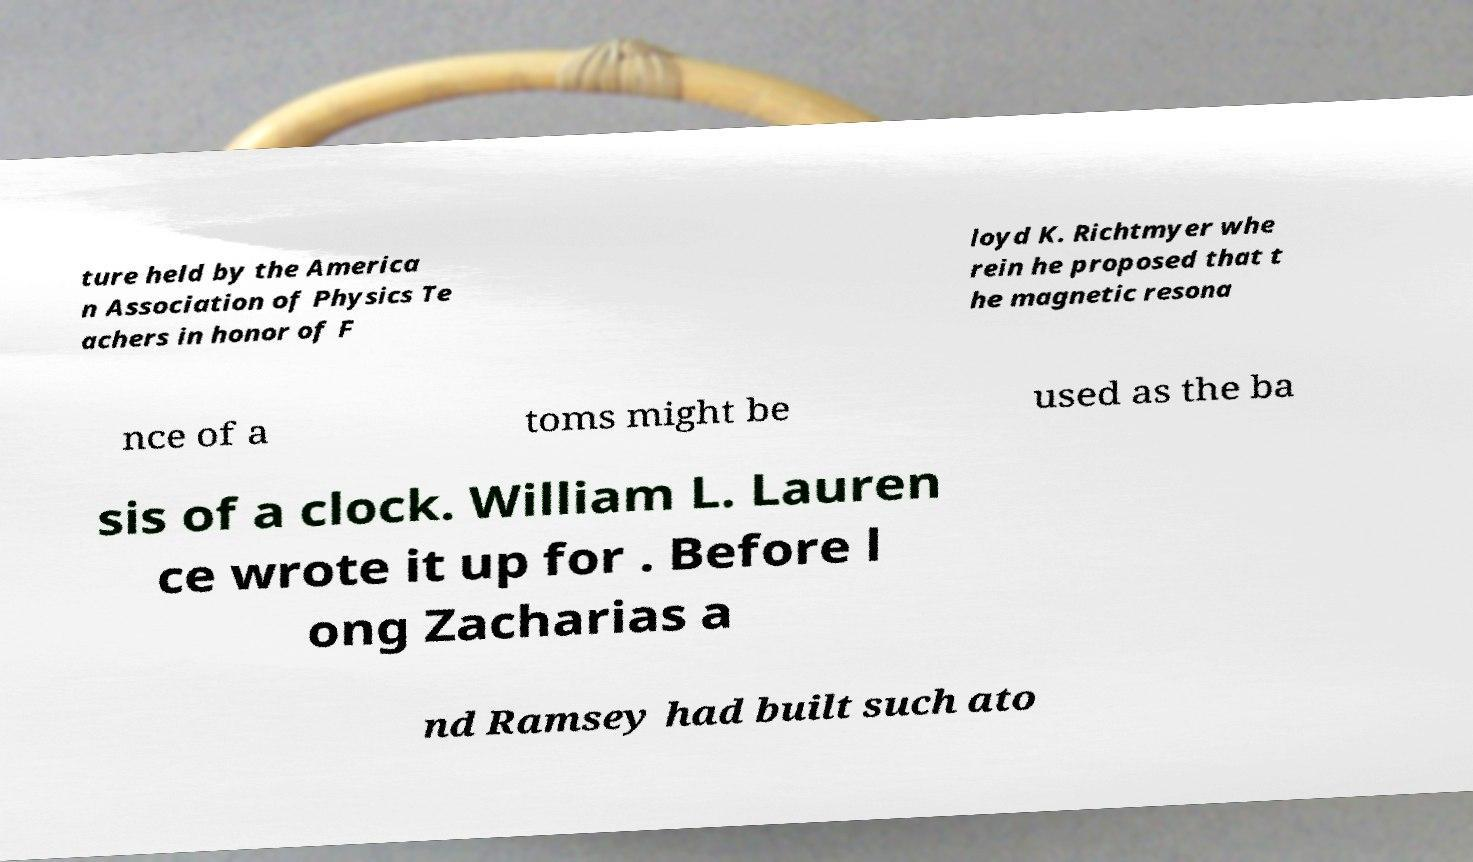Could you extract and type out the text from this image? ture held by the America n Association of Physics Te achers in honor of F loyd K. Richtmyer whe rein he proposed that t he magnetic resona nce of a toms might be used as the ba sis of a clock. William L. Lauren ce wrote it up for . Before l ong Zacharias a nd Ramsey had built such ato 